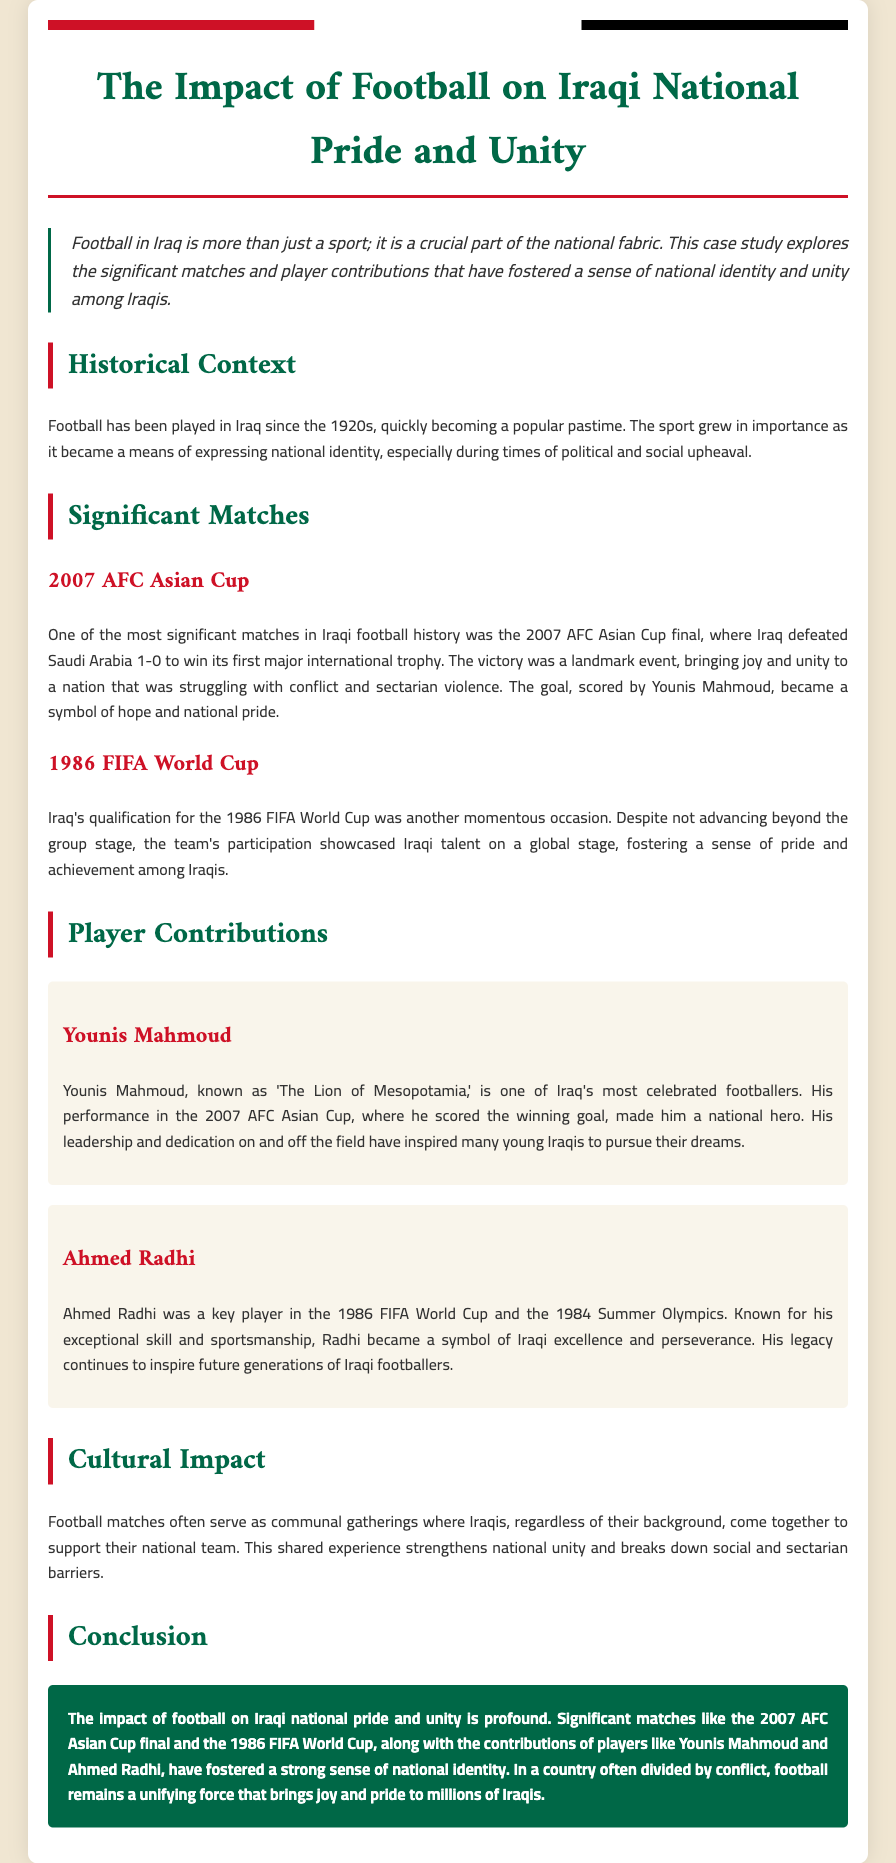what year did Iraq win the AFC Asian Cup? The document states that Iraq won the AFC Asian Cup in 2007 by defeating Saudi Arabia.
Answer: 2007 who scored the winning goal in the 2007 AFC Asian Cup final? The document mentions that Younis Mahmoud scored the winning goal in the match.
Answer: Younis Mahmoud what major international tournament did Iraq participate in 1986? The document notes that Iraq qualified for the FIFA World Cup in 1986.
Answer: FIFA World Cup what was Ahmed Radhi known for? The document describes Ahmed Radhi as a key player in the 1986 FIFA World Cup known for his exceptional skill and sportsmanship.
Answer: Exceptional skill and sportsmanship how did football affect national unity among Iraqis? The document explains that football matches serve as communal gatherings, strengthening national unity and breaking down barriers.
Answer: Strengthened national unity what is Younis Mahmoud's nickname? The document refers to Younis Mahmoud as 'The Lion of Mesopotamia.'
Answer: The Lion of Mesopotamia what type of gatherings do football matches create in Iraq? According to the document, football matches create communal gatherings for Iraqis to support their national team.
Answer: Communal gatherings what is the overall conclusion about football's impact on Iraq? The conclusion emphasizes that football profoundly impacts Iraqi national pride and unity.
Answer: Profound impact on national pride and unity 